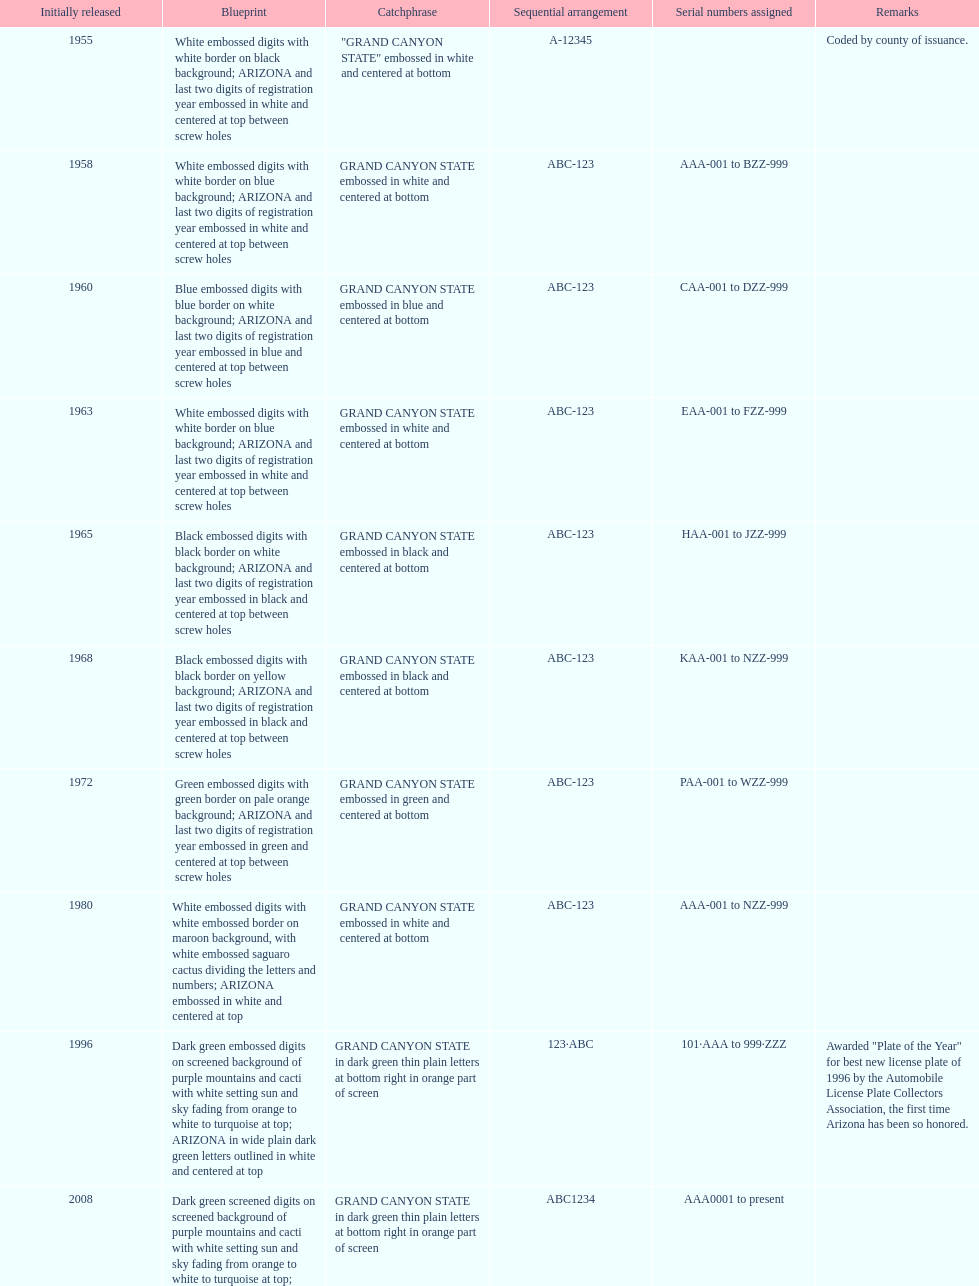Name the year of the license plate that has the largest amount of alphanumeric digits. 2008. 